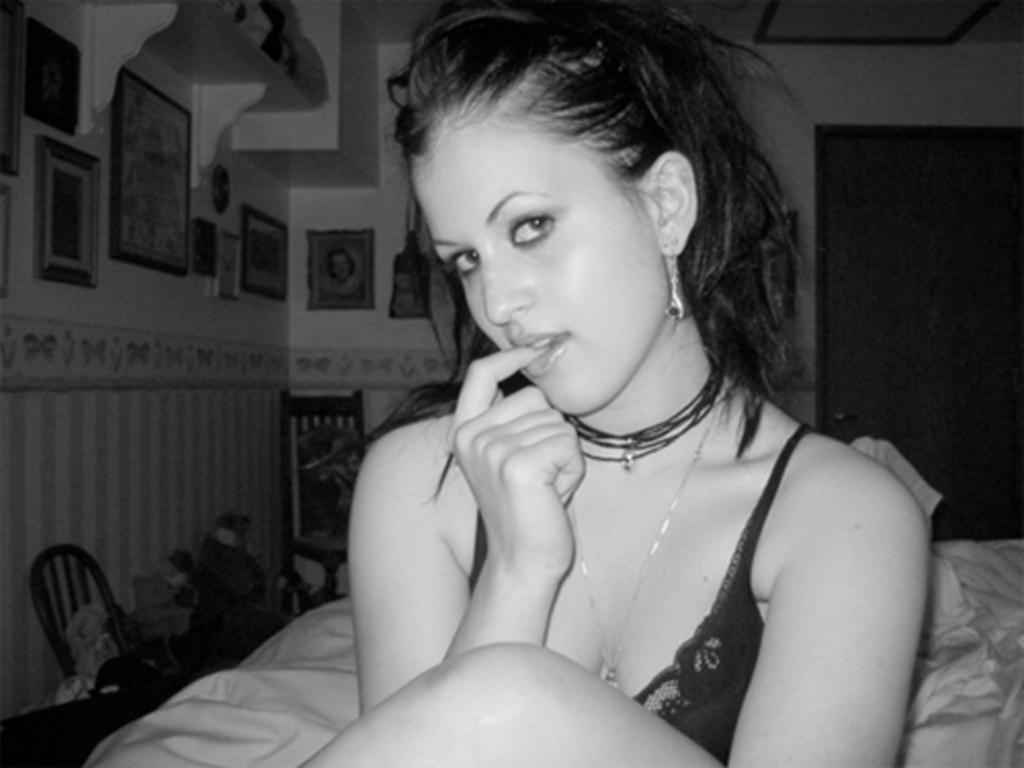In one or two sentences, can you explain what this image depicts? This is a black and white picture. Here we can see a woman, cloth, chair, and few objects. In the background we can see wall, door, and frames. 